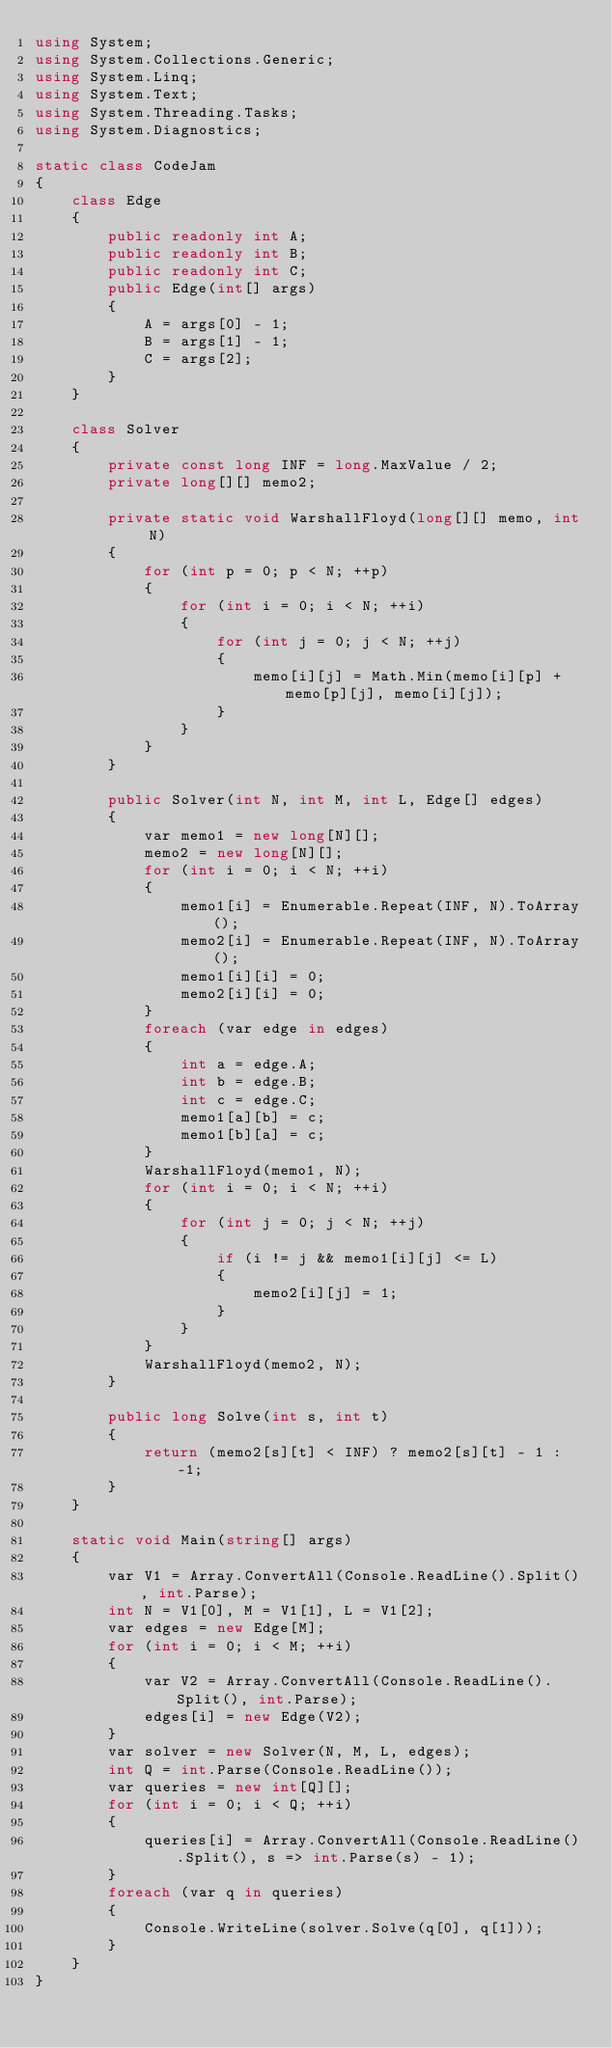<code> <loc_0><loc_0><loc_500><loc_500><_C#_>using System;
using System.Collections.Generic;
using System.Linq;
using System.Text;
using System.Threading.Tasks;
using System.Diagnostics;

static class CodeJam
{
    class Edge
    {
        public readonly int A;
        public readonly int B;
        public readonly int C;
        public Edge(int[] args)
        {
            A = args[0] - 1;
            B = args[1] - 1;
            C = args[2];
        }
    }

    class Solver
    {
        private const long INF = long.MaxValue / 2;
        private long[][] memo2;

        private static void WarshallFloyd(long[][] memo, int N)
        {
            for (int p = 0; p < N; ++p)
            {
                for (int i = 0; i < N; ++i)
                {
                    for (int j = 0; j < N; ++j)
                    {
                        memo[i][j] = Math.Min(memo[i][p] + memo[p][j], memo[i][j]);
                    }
                }
            }
        }

        public Solver(int N, int M, int L, Edge[] edges)
        {
            var memo1 = new long[N][];
            memo2 = new long[N][];
            for (int i = 0; i < N; ++i)
            {
                memo1[i] = Enumerable.Repeat(INF, N).ToArray();
                memo2[i] = Enumerable.Repeat(INF, N).ToArray();
                memo1[i][i] = 0;
                memo2[i][i] = 0;
            }
            foreach (var edge in edges)
            {
                int a = edge.A;
                int b = edge.B;
                int c = edge.C;
                memo1[a][b] = c;
                memo1[b][a] = c;
            }
            WarshallFloyd(memo1, N);
            for (int i = 0; i < N; ++i)
            {
                for (int j = 0; j < N; ++j)
                {
                    if (i != j && memo1[i][j] <= L)
                    {
                        memo2[i][j] = 1;
                    }
                }
            }
            WarshallFloyd(memo2, N);
        }

        public long Solve(int s, int t)
        {
            return (memo2[s][t] < INF) ? memo2[s][t] - 1 : -1;
        }
    }

    static void Main(string[] args)
    {
        var V1 = Array.ConvertAll(Console.ReadLine().Split(), int.Parse);
        int N = V1[0], M = V1[1], L = V1[2];
        var edges = new Edge[M];
        for (int i = 0; i < M; ++i)
        {
            var V2 = Array.ConvertAll(Console.ReadLine().Split(), int.Parse);
            edges[i] = new Edge(V2);
        }
        var solver = new Solver(N, M, L, edges);
        int Q = int.Parse(Console.ReadLine());
        var queries = new int[Q][];
        for (int i = 0; i < Q; ++i)
        {
            queries[i] = Array.ConvertAll(Console.ReadLine().Split(), s => int.Parse(s) - 1);
        }
        foreach (var q in queries)
        {
            Console.WriteLine(solver.Solve(q[0], q[1]));
        }
    }
}
</code> 